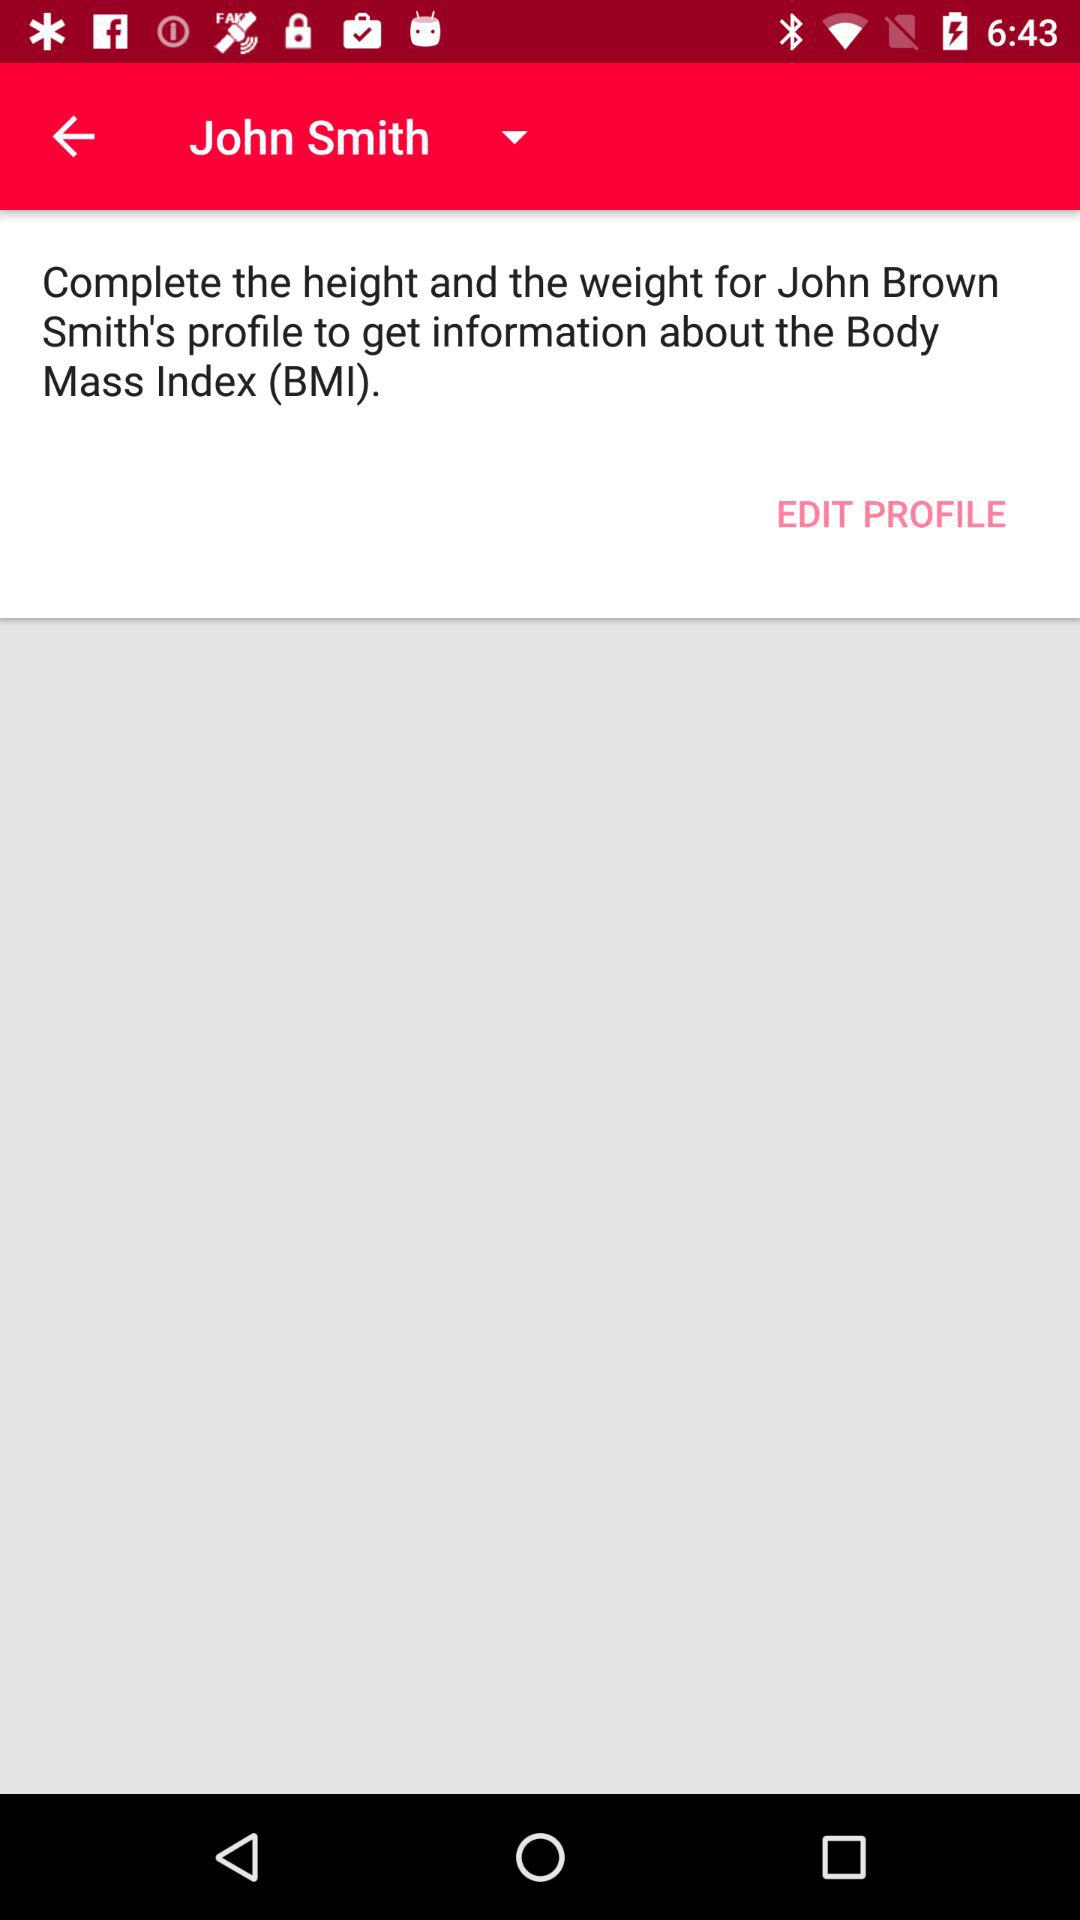What is the full form of BMI? The full form of BMI is Body Mass Index. 